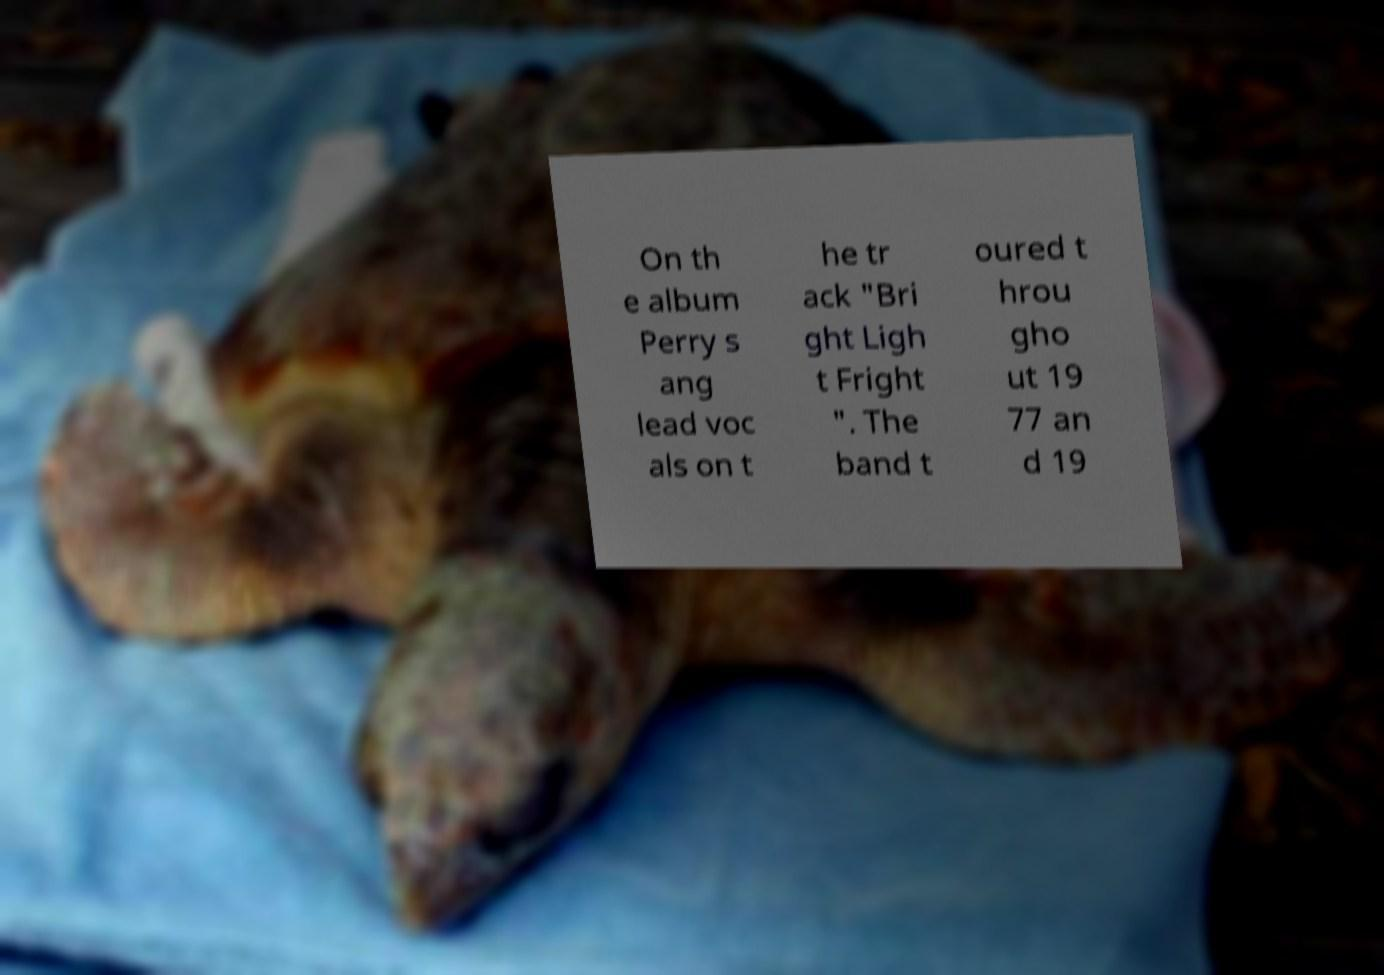Please read and relay the text visible in this image. What does it say? On th e album Perry s ang lead voc als on t he tr ack "Bri ght Ligh t Fright ". The band t oured t hrou gho ut 19 77 an d 19 